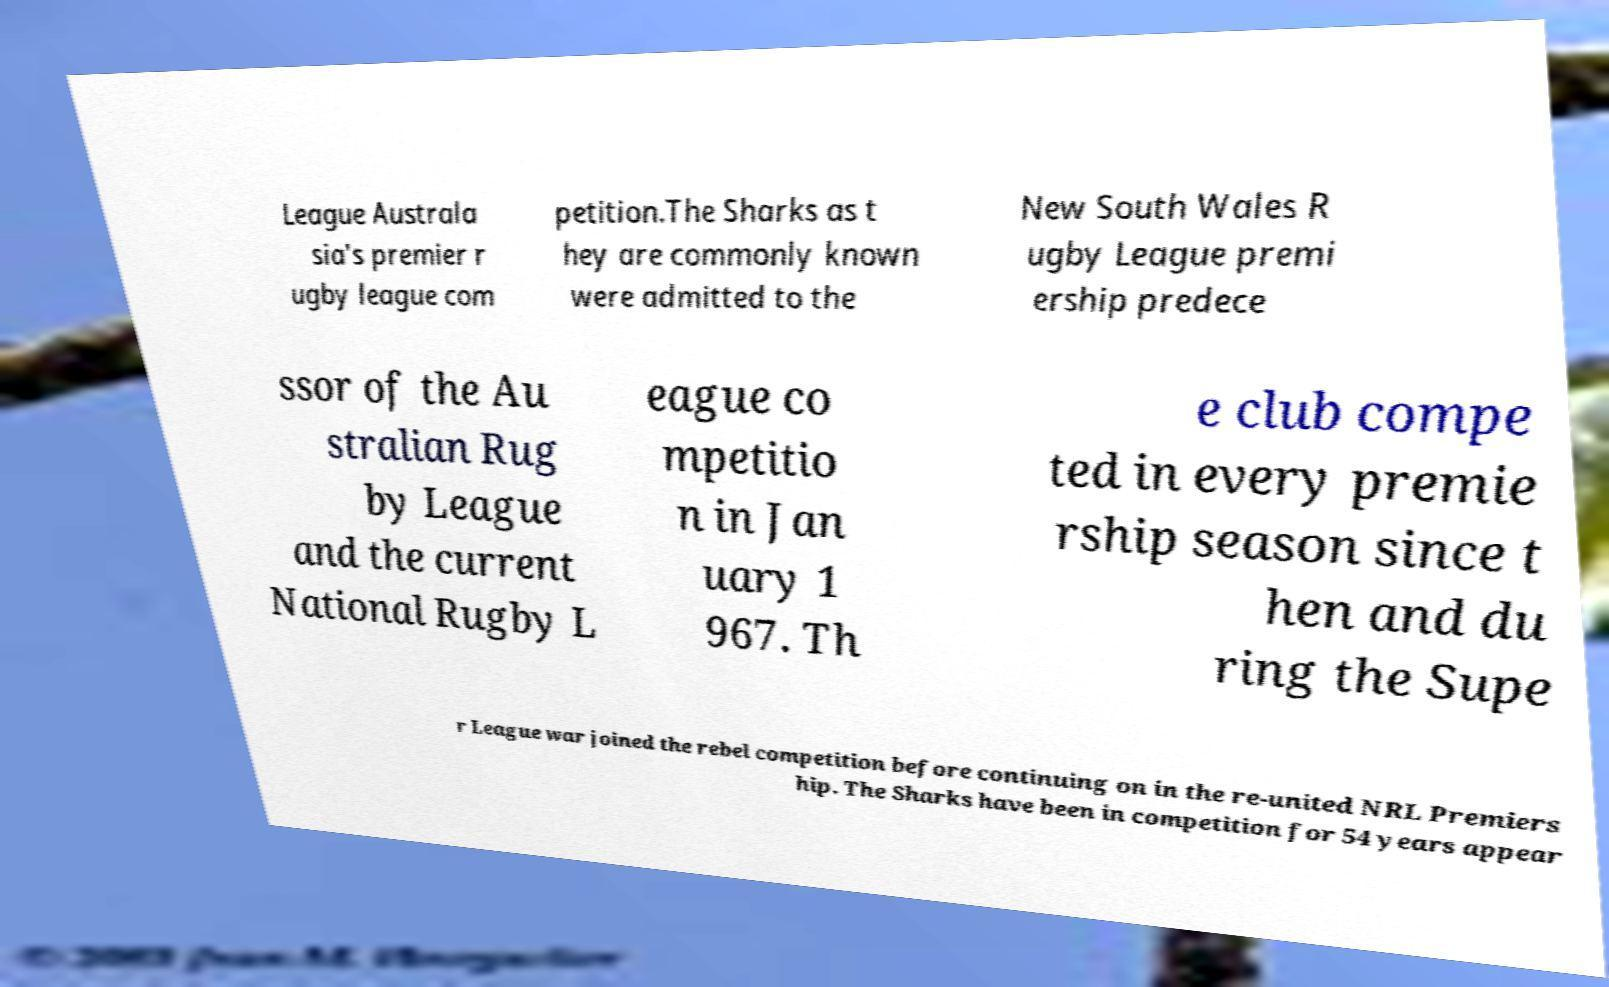I need the written content from this picture converted into text. Can you do that? League Australa sia's premier r ugby league com petition.The Sharks as t hey are commonly known were admitted to the New South Wales R ugby League premi ership predece ssor of the Au stralian Rug by League and the current National Rugby L eague co mpetitio n in Jan uary 1 967. Th e club compe ted in every premie rship season since t hen and du ring the Supe r League war joined the rebel competition before continuing on in the re-united NRL Premiers hip. The Sharks have been in competition for 54 years appear 